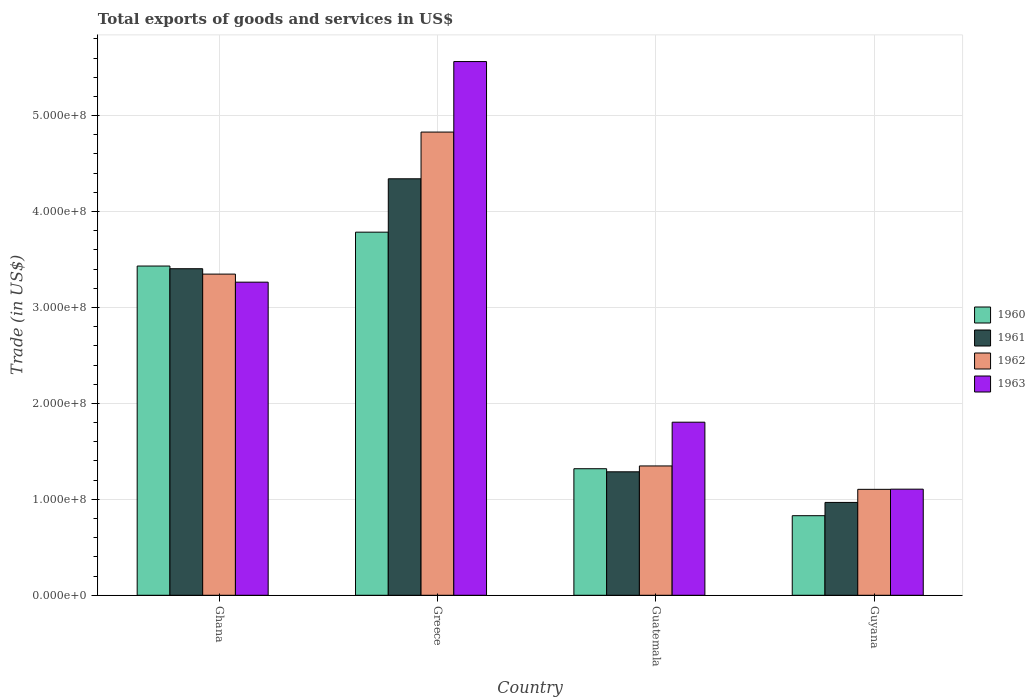How many different coloured bars are there?
Offer a very short reply. 4. How many groups of bars are there?
Your response must be concise. 4. How many bars are there on the 2nd tick from the right?
Provide a succinct answer. 4. What is the label of the 3rd group of bars from the left?
Your answer should be very brief. Guatemala. What is the total exports of goods and services in 1960 in Ghana?
Your response must be concise. 3.43e+08. Across all countries, what is the maximum total exports of goods and services in 1960?
Your answer should be compact. 3.78e+08. Across all countries, what is the minimum total exports of goods and services in 1963?
Offer a terse response. 1.11e+08. In which country was the total exports of goods and services in 1960 minimum?
Your answer should be very brief. Guyana. What is the total total exports of goods and services in 1961 in the graph?
Provide a succinct answer. 1.00e+09. What is the difference between the total exports of goods and services in 1963 in Ghana and that in Guyana?
Keep it short and to the point. 2.16e+08. What is the difference between the total exports of goods and services in 1960 in Guatemala and the total exports of goods and services in 1962 in Guyana?
Give a very brief answer. 2.15e+07. What is the average total exports of goods and services in 1960 per country?
Offer a very short reply. 2.34e+08. What is the difference between the total exports of goods and services of/in 1961 and total exports of goods and services of/in 1962 in Greece?
Offer a very short reply. -4.87e+07. What is the ratio of the total exports of goods and services in 1963 in Ghana to that in Guatemala?
Make the answer very short. 1.81. Is the total exports of goods and services in 1962 in Ghana less than that in Guatemala?
Your answer should be very brief. No. Is the difference between the total exports of goods and services in 1961 in Greece and Guyana greater than the difference between the total exports of goods and services in 1962 in Greece and Guyana?
Keep it short and to the point. No. What is the difference between the highest and the second highest total exports of goods and services in 1960?
Your answer should be very brief. -2.11e+08. What is the difference between the highest and the lowest total exports of goods and services in 1962?
Provide a short and direct response. 3.72e+08. In how many countries, is the total exports of goods and services in 1960 greater than the average total exports of goods and services in 1960 taken over all countries?
Keep it short and to the point. 2. Is the sum of the total exports of goods and services in 1961 in Guatemala and Guyana greater than the maximum total exports of goods and services in 1963 across all countries?
Your response must be concise. No. Is it the case that in every country, the sum of the total exports of goods and services in 1961 and total exports of goods and services in 1960 is greater than the sum of total exports of goods and services in 1962 and total exports of goods and services in 1963?
Your answer should be compact. No. Is it the case that in every country, the sum of the total exports of goods and services in 1963 and total exports of goods and services in 1962 is greater than the total exports of goods and services in 1961?
Your response must be concise. Yes. Are all the bars in the graph horizontal?
Ensure brevity in your answer.  No. How many countries are there in the graph?
Give a very brief answer. 4. Are the values on the major ticks of Y-axis written in scientific E-notation?
Provide a short and direct response. Yes. Does the graph contain any zero values?
Your answer should be very brief. No. Does the graph contain grids?
Your answer should be very brief. Yes. Where does the legend appear in the graph?
Provide a succinct answer. Center right. What is the title of the graph?
Your response must be concise. Total exports of goods and services in US$. Does "1978" appear as one of the legend labels in the graph?
Keep it short and to the point. No. What is the label or title of the Y-axis?
Offer a terse response. Trade (in US$). What is the Trade (in US$) in 1960 in Ghana?
Provide a short and direct response. 3.43e+08. What is the Trade (in US$) in 1961 in Ghana?
Make the answer very short. 3.40e+08. What is the Trade (in US$) of 1962 in Ghana?
Make the answer very short. 3.35e+08. What is the Trade (in US$) of 1963 in Ghana?
Provide a succinct answer. 3.26e+08. What is the Trade (in US$) of 1960 in Greece?
Ensure brevity in your answer.  3.78e+08. What is the Trade (in US$) in 1961 in Greece?
Provide a succinct answer. 4.34e+08. What is the Trade (in US$) of 1962 in Greece?
Provide a succinct answer. 4.83e+08. What is the Trade (in US$) in 1963 in Greece?
Ensure brevity in your answer.  5.56e+08. What is the Trade (in US$) of 1960 in Guatemala?
Your response must be concise. 1.32e+08. What is the Trade (in US$) in 1961 in Guatemala?
Give a very brief answer. 1.29e+08. What is the Trade (in US$) of 1962 in Guatemala?
Provide a succinct answer. 1.35e+08. What is the Trade (in US$) of 1963 in Guatemala?
Your answer should be very brief. 1.80e+08. What is the Trade (in US$) in 1960 in Guyana?
Keep it short and to the point. 8.29e+07. What is the Trade (in US$) in 1961 in Guyana?
Keep it short and to the point. 9.68e+07. What is the Trade (in US$) in 1962 in Guyana?
Make the answer very short. 1.10e+08. What is the Trade (in US$) in 1963 in Guyana?
Your answer should be compact. 1.11e+08. Across all countries, what is the maximum Trade (in US$) in 1960?
Ensure brevity in your answer.  3.78e+08. Across all countries, what is the maximum Trade (in US$) in 1961?
Keep it short and to the point. 4.34e+08. Across all countries, what is the maximum Trade (in US$) of 1962?
Give a very brief answer. 4.83e+08. Across all countries, what is the maximum Trade (in US$) in 1963?
Your answer should be compact. 5.56e+08. Across all countries, what is the minimum Trade (in US$) in 1960?
Make the answer very short. 8.29e+07. Across all countries, what is the minimum Trade (in US$) of 1961?
Keep it short and to the point. 9.68e+07. Across all countries, what is the minimum Trade (in US$) of 1962?
Provide a succinct answer. 1.10e+08. Across all countries, what is the minimum Trade (in US$) in 1963?
Ensure brevity in your answer.  1.11e+08. What is the total Trade (in US$) in 1960 in the graph?
Keep it short and to the point. 9.37e+08. What is the total Trade (in US$) of 1961 in the graph?
Provide a succinct answer. 1.00e+09. What is the total Trade (in US$) in 1962 in the graph?
Provide a short and direct response. 1.06e+09. What is the total Trade (in US$) of 1963 in the graph?
Keep it short and to the point. 1.17e+09. What is the difference between the Trade (in US$) of 1960 in Ghana and that in Greece?
Make the answer very short. -3.53e+07. What is the difference between the Trade (in US$) in 1961 in Ghana and that in Greece?
Your response must be concise. -9.37e+07. What is the difference between the Trade (in US$) in 1962 in Ghana and that in Greece?
Your answer should be very brief. -1.48e+08. What is the difference between the Trade (in US$) in 1963 in Ghana and that in Greece?
Give a very brief answer. -2.30e+08. What is the difference between the Trade (in US$) of 1960 in Ghana and that in Guatemala?
Offer a terse response. 2.11e+08. What is the difference between the Trade (in US$) in 1961 in Ghana and that in Guatemala?
Provide a succinct answer. 2.12e+08. What is the difference between the Trade (in US$) in 1962 in Ghana and that in Guatemala?
Ensure brevity in your answer.  2.00e+08. What is the difference between the Trade (in US$) of 1963 in Ghana and that in Guatemala?
Keep it short and to the point. 1.46e+08. What is the difference between the Trade (in US$) of 1960 in Ghana and that in Guyana?
Ensure brevity in your answer.  2.60e+08. What is the difference between the Trade (in US$) of 1961 in Ghana and that in Guyana?
Offer a very short reply. 2.44e+08. What is the difference between the Trade (in US$) of 1962 in Ghana and that in Guyana?
Your response must be concise. 2.24e+08. What is the difference between the Trade (in US$) of 1963 in Ghana and that in Guyana?
Make the answer very short. 2.16e+08. What is the difference between the Trade (in US$) in 1960 in Greece and that in Guatemala?
Your response must be concise. 2.47e+08. What is the difference between the Trade (in US$) in 1961 in Greece and that in Guatemala?
Provide a succinct answer. 3.05e+08. What is the difference between the Trade (in US$) of 1962 in Greece and that in Guatemala?
Your answer should be very brief. 3.48e+08. What is the difference between the Trade (in US$) of 1963 in Greece and that in Guatemala?
Ensure brevity in your answer.  3.76e+08. What is the difference between the Trade (in US$) in 1960 in Greece and that in Guyana?
Offer a terse response. 2.96e+08. What is the difference between the Trade (in US$) in 1961 in Greece and that in Guyana?
Provide a short and direct response. 3.37e+08. What is the difference between the Trade (in US$) of 1962 in Greece and that in Guyana?
Offer a very short reply. 3.72e+08. What is the difference between the Trade (in US$) of 1963 in Greece and that in Guyana?
Give a very brief answer. 4.46e+08. What is the difference between the Trade (in US$) in 1960 in Guatemala and that in Guyana?
Make the answer very short. 4.90e+07. What is the difference between the Trade (in US$) in 1961 in Guatemala and that in Guyana?
Provide a succinct answer. 3.19e+07. What is the difference between the Trade (in US$) of 1962 in Guatemala and that in Guyana?
Make the answer very short. 2.44e+07. What is the difference between the Trade (in US$) of 1963 in Guatemala and that in Guyana?
Make the answer very short. 6.98e+07. What is the difference between the Trade (in US$) in 1960 in Ghana and the Trade (in US$) in 1961 in Greece?
Ensure brevity in your answer.  -9.09e+07. What is the difference between the Trade (in US$) in 1960 in Ghana and the Trade (in US$) in 1962 in Greece?
Make the answer very short. -1.40e+08. What is the difference between the Trade (in US$) in 1960 in Ghana and the Trade (in US$) in 1963 in Greece?
Provide a succinct answer. -2.13e+08. What is the difference between the Trade (in US$) of 1961 in Ghana and the Trade (in US$) of 1962 in Greece?
Keep it short and to the point. -1.42e+08. What is the difference between the Trade (in US$) of 1961 in Ghana and the Trade (in US$) of 1963 in Greece?
Offer a very short reply. -2.16e+08. What is the difference between the Trade (in US$) of 1962 in Ghana and the Trade (in US$) of 1963 in Greece?
Provide a succinct answer. -2.22e+08. What is the difference between the Trade (in US$) of 1960 in Ghana and the Trade (in US$) of 1961 in Guatemala?
Keep it short and to the point. 2.14e+08. What is the difference between the Trade (in US$) of 1960 in Ghana and the Trade (in US$) of 1962 in Guatemala?
Provide a succinct answer. 2.08e+08. What is the difference between the Trade (in US$) of 1960 in Ghana and the Trade (in US$) of 1963 in Guatemala?
Your response must be concise. 1.63e+08. What is the difference between the Trade (in US$) in 1961 in Ghana and the Trade (in US$) in 1962 in Guatemala?
Make the answer very short. 2.06e+08. What is the difference between the Trade (in US$) of 1961 in Ghana and the Trade (in US$) of 1963 in Guatemala?
Provide a short and direct response. 1.60e+08. What is the difference between the Trade (in US$) of 1962 in Ghana and the Trade (in US$) of 1963 in Guatemala?
Keep it short and to the point. 1.54e+08. What is the difference between the Trade (in US$) in 1960 in Ghana and the Trade (in US$) in 1961 in Guyana?
Offer a terse response. 2.46e+08. What is the difference between the Trade (in US$) in 1960 in Ghana and the Trade (in US$) in 1962 in Guyana?
Give a very brief answer. 2.33e+08. What is the difference between the Trade (in US$) in 1960 in Ghana and the Trade (in US$) in 1963 in Guyana?
Your answer should be compact. 2.33e+08. What is the difference between the Trade (in US$) of 1961 in Ghana and the Trade (in US$) of 1962 in Guyana?
Keep it short and to the point. 2.30e+08. What is the difference between the Trade (in US$) of 1961 in Ghana and the Trade (in US$) of 1963 in Guyana?
Give a very brief answer. 2.30e+08. What is the difference between the Trade (in US$) in 1962 in Ghana and the Trade (in US$) in 1963 in Guyana?
Provide a succinct answer. 2.24e+08. What is the difference between the Trade (in US$) of 1960 in Greece and the Trade (in US$) of 1961 in Guatemala?
Your answer should be very brief. 2.50e+08. What is the difference between the Trade (in US$) in 1960 in Greece and the Trade (in US$) in 1962 in Guatemala?
Your answer should be very brief. 2.44e+08. What is the difference between the Trade (in US$) of 1960 in Greece and the Trade (in US$) of 1963 in Guatemala?
Offer a very short reply. 1.98e+08. What is the difference between the Trade (in US$) in 1961 in Greece and the Trade (in US$) in 1962 in Guatemala?
Offer a terse response. 2.99e+08. What is the difference between the Trade (in US$) of 1961 in Greece and the Trade (in US$) of 1963 in Guatemala?
Provide a short and direct response. 2.54e+08. What is the difference between the Trade (in US$) in 1962 in Greece and the Trade (in US$) in 1963 in Guatemala?
Provide a short and direct response. 3.02e+08. What is the difference between the Trade (in US$) of 1960 in Greece and the Trade (in US$) of 1961 in Guyana?
Offer a terse response. 2.82e+08. What is the difference between the Trade (in US$) in 1960 in Greece and the Trade (in US$) in 1962 in Guyana?
Provide a short and direct response. 2.68e+08. What is the difference between the Trade (in US$) in 1960 in Greece and the Trade (in US$) in 1963 in Guyana?
Offer a terse response. 2.68e+08. What is the difference between the Trade (in US$) in 1961 in Greece and the Trade (in US$) in 1962 in Guyana?
Your answer should be very brief. 3.24e+08. What is the difference between the Trade (in US$) of 1961 in Greece and the Trade (in US$) of 1963 in Guyana?
Your answer should be very brief. 3.24e+08. What is the difference between the Trade (in US$) of 1962 in Greece and the Trade (in US$) of 1963 in Guyana?
Your answer should be very brief. 3.72e+08. What is the difference between the Trade (in US$) in 1960 in Guatemala and the Trade (in US$) in 1961 in Guyana?
Make the answer very short. 3.51e+07. What is the difference between the Trade (in US$) in 1960 in Guatemala and the Trade (in US$) in 1962 in Guyana?
Provide a short and direct response. 2.15e+07. What is the difference between the Trade (in US$) in 1960 in Guatemala and the Trade (in US$) in 1963 in Guyana?
Give a very brief answer. 2.13e+07. What is the difference between the Trade (in US$) in 1961 in Guatemala and the Trade (in US$) in 1962 in Guyana?
Your answer should be compact. 1.83e+07. What is the difference between the Trade (in US$) in 1961 in Guatemala and the Trade (in US$) in 1963 in Guyana?
Provide a succinct answer. 1.81e+07. What is the difference between the Trade (in US$) of 1962 in Guatemala and the Trade (in US$) of 1963 in Guyana?
Provide a succinct answer. 2.42e+07. What is the average Trade (in US$) of 1960 per country?
Give a very brief answer. 2.34e+08. What is the average Trade (in US$) of 1961 per country?
Offer a terse response. 2.50e+08. What is the average Trade (in US$) of 1962 per country?
Provide a succinct answer. 2.66e+08. What is the average Trade (in US$) in 1963 per country?
Provide a short and direct response. 2.93e+08. What is the difference between the Trade (in US$) in 1960 and Trade (in US$) in 1961 in Ghana?
Keep it short and to the point. 2.80e+06. What is the difference between the Trade (in US$) in 1960 and Trade (in US$) in 1962 in Ghana?
Offer a very short reply. 8.40e+06. What is the difference between the Trade (in US$) of 1960 and Trade (in US$) of 1963 in Ghana?
Your response must be concise. 1.68e+07. What is the difference between the Trade (in US$) of 1961 and Trade (in US$) of 1962 in Ghana?
Keep it short and to the point. 5.60e+06. What is the difference between the Trade (in US$) in 1961 and Trade (in US$) in 1963 in Ghana?
Your answer should be very brief. 1.40e+07. What is the difference between the Trade (in US$) of 1962 and Trade (in US$) of 1963 in Ghana?
Ensure brevity in your answer.  8.40e+06. What is the difference between the Trade (in US$) of 1960 and Trade (in US$) of 1961 in Greece?
Offer a very short reply. -5.56e+07. What is the difference between the Trade (in US$) of 1960 and Trade (in US$) of 1962 in Greece?
Provide a succinct answer. -1.04e+08. What is the difference between the Trade (in US$) in 1960 and Trade (in US$) in 1963 in Greece?
Your response must be concise. -1.78e+08. What is the difference between the Trade (in US$) in 1961 and Trade (in US$) in 1962 in Greece?
Your response must be concise. -4.87e+07. What is the difference between the Trade (in US$) of 1961 and Trade (in US$) of 1963 in Greece?
Give a very brief answer. -1.22e+08. What is the difference between the Trade (in US$) in 1962 and Trade (in US$) in 1963 in Greece?
Provide a succinct answer. -7.35e+07. What is the difference between the Trade (in US$) of 1960 and Trade (in US$) of 1961 in Guatemala?
Your response must be concise. 3.20e+06. What is the difference between the Trade (in US$) of 1960 and Trade (in US$) of 1962 in Guatemala?
Provide a short and direct response. -2.90e+06. What is the difference between the Trade (in US$) in 1960 and Trade (in US$) in 1963 in Guatemala?
Provide a short and direct response. -4.85e+07. What is the difference between the Trade (in US$) of 1961 and Trade (in US$) of 1962 in Guatemala?
Keep it short and to the point. -6.10e+06. What is the difference between the Trade (in US$) of 1961 and Trade (in US$) of 1963 in Guatemala?
Keep it short and to the point. -5.17e+07. What is the difference between the Trade (in US$) of 1962 and Trade (in US$) of 1963 in Guatemala?
Provide a short and direct response. -4.56e+07. What is the difference between the Trade (in US$) in 1960 and Trade (in US$) in 1961 in Guyana?
Your answer should be very brief. -1.38e+07. What is the difference between the Trade (in US$) in 1960 and Trade (in US$) in 1962 in Guyana?
Your answer should be compact. -2.75e+07. What is the difference between the Trade (in US$) of 1960 and Trade (in US$) of 1963 in Guyana?
Offer a terse response. -2.76e+07. What is the difference between the Trade (in US$) in 1961 and Trade (in US$) in 1962 in Guyana?
Offer a very short reply. -1.36e+07. What is the difference between the Trade (in US$) of 1961 and Trade (in US$) of 1963 in Guyana?
Make the answer very short. -1.38e+07. What is the difference between the Trade (in US$) of 1962 and Trade (in US$) of 1963 in Guyana?
Give a very brief answer. -1.75e+05. What is the ratio of the Trade (in US$) in 1960 in Ghana to that in Greece?
Your answer should be very brief. 0.91. What is the ratio of the Trade (in US$) in 1961 in Ghana to that in Greece?
Keep it short and to the point. 0.78. What is the ratio of the Trade (in US$) in 1962 in Ghana to that in Greece?
Your response must be concise. 0.69. What is the ratio of the Trade (in US$) of 1963 in Ghana to that in Greece?
Ensure brevity in your answer.  0.59. What is the ratio of the Trade (in US$) in 1960 in Ghana to that in Guatemala?
Provide a succinct answer. 2.6. What is the ratio of the Trade (in US$) of 1961 in Ghana to that in Guatemala?
Provide a short and direct response. 2.64. What is the ratio of the Trade (in US$) in 1962 in Ghana to that in Guatemala?
Your response must be concise. 2.48. What is the ratio of the Trade (in US$) of 1963 in Ghana to that in Guatemala?
Provide a succinct answer. 1.81. What is the ratio of the Trade (in US$) in 1960 in Ghana to that in Guyana?
Give a very brief answer. 4.14. What is the ratio of the Trade (in US$) in 1961 in Ghana to that in Guyana?
Keep it short and to the point. 3.52. What is the ratio of the Trade (in US$) of 1962 in Ghana to that in Guyana?
Keep it short and to the point. 3.03. What is the ratio of the Trade (in US$) in 1963 in Ghana to that in Guyana?
Provide a succinct answer. 2.95. What is the ratio of the Trade (in US$) in 1960 in Greece to that in Guatemala?
Offer a very short reply. 2.87. What is the ratio of the Trade (in US$) in 1961 in Greece to that in Guatemala?
Offer a very short reply. 3.37. What is the ratio of the Trade (in US$) of 1962 in Greece to that in Guatemala?
Give a very brief answer. 3.58. What is the ratio of the Trade (in US$) of 1963 in Greece to that in Guatemala?
Ensure brevity in your answer.  3.08. What is the ratio of the Trade (in US$) in 1960 in Greece to that in Guyana?
Your answer should be compact. 4.56. What is the ratio of the Trade (in US$) in 1961 in Greece to that in Guyana?
Give a very brief answer. 4.49. What is the ratio of the Trade (in US$) of 1962 in Greece to that in Guyana?
Provide a short and direct response. 4.37. What is the ratio of the Trade (in US$) in 1963 in Greece to that in Guyana?
Your answer should be very brief. 5.03. What is the ratio of the Trade (in US$) of 1960 in Guatemala to that in Guyana?
Make the answer very short. 1.59. What is the ratio of the Trade (in US$) of 1961 in Guatemala to that in Guyana?
Your response must be concise. 1.33. What is the ratio of the Trade (in US$) in 1962 in Guatemala to that in Guyana?
Provide a short and direct response. 1.22. What is the ratio of the Trade (in US$) of 1963 in Guatemala to that in Guyana?
Make the answer very short. 1.63. What is the difference between the highest and the second highest Trade (in US$) of 1960?
Make the answer very short. 3.53e+07. What is the difference between the highest and the second highest Trade (in US$) of 1961?
Your response must be concise. 9.37e+07. What is the difference between the highest and the second highest Trade (in US$) in 1962?
Your answer should be compact. 1.48e+08. What is the difference between the highest and the second highest Trade (in US$) of 1963?
Keep it short and to the point. 2.30e+08. What is the difference between the highest and the lowest Trade (in US$) of 1960?
Provide a short and direct response. 2.96e+08. What is the difference between the highest and the lowest Trade (in US$) of 1961?
Ensure brevity in your answer.  3.37e+08. What is the difference between the highest and the lowest Trade (in US$) of 1962?
Ensure brevity in your answer.  3.72e+08. What is the difference between the highest and the lowest Trade (in US$) in 1963?
Your answer should be compact. 4.46e+08. 